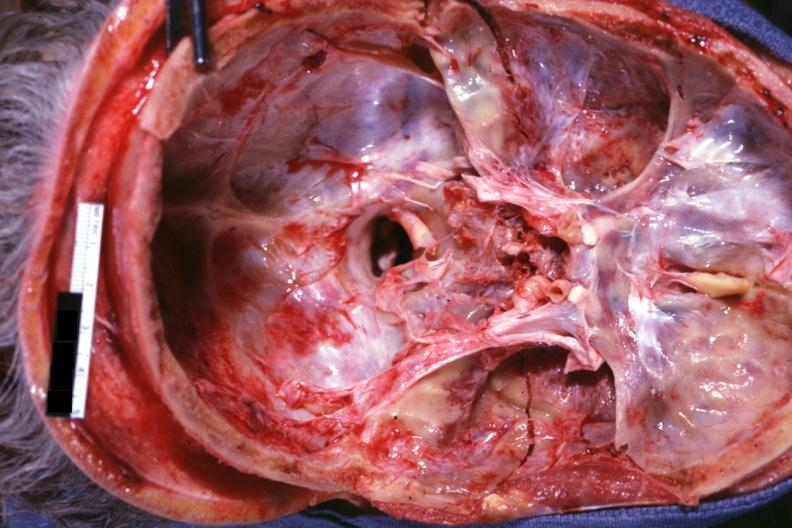what is present?
Answer the question using a single word or phrase. Basilar skull fracture 